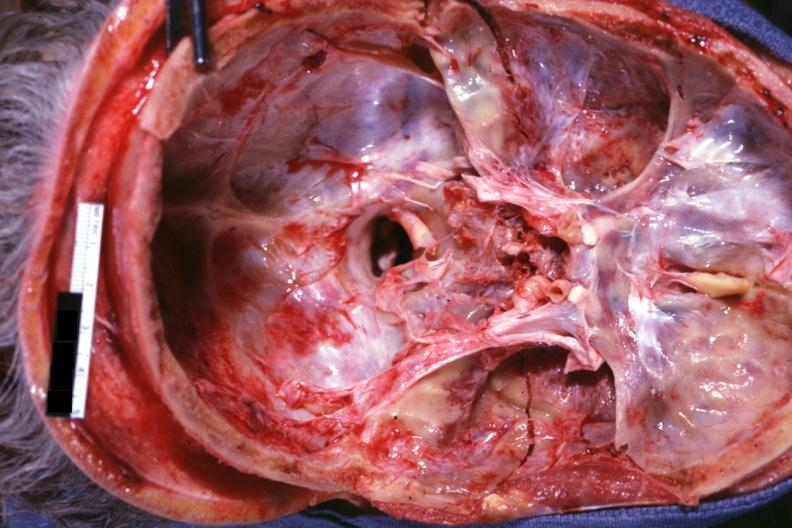what is present?
Answer the question using a single word or phrase. Basilar skull fracture 